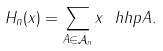Convert formula to latex. <formula><loc_0><loc_0><loc_500><loc_500>H _ { n } ( x ) = \sum _ { A \in \mathcal { A } _ { n } } x ^ { \ } h h p { A } .</formula> 